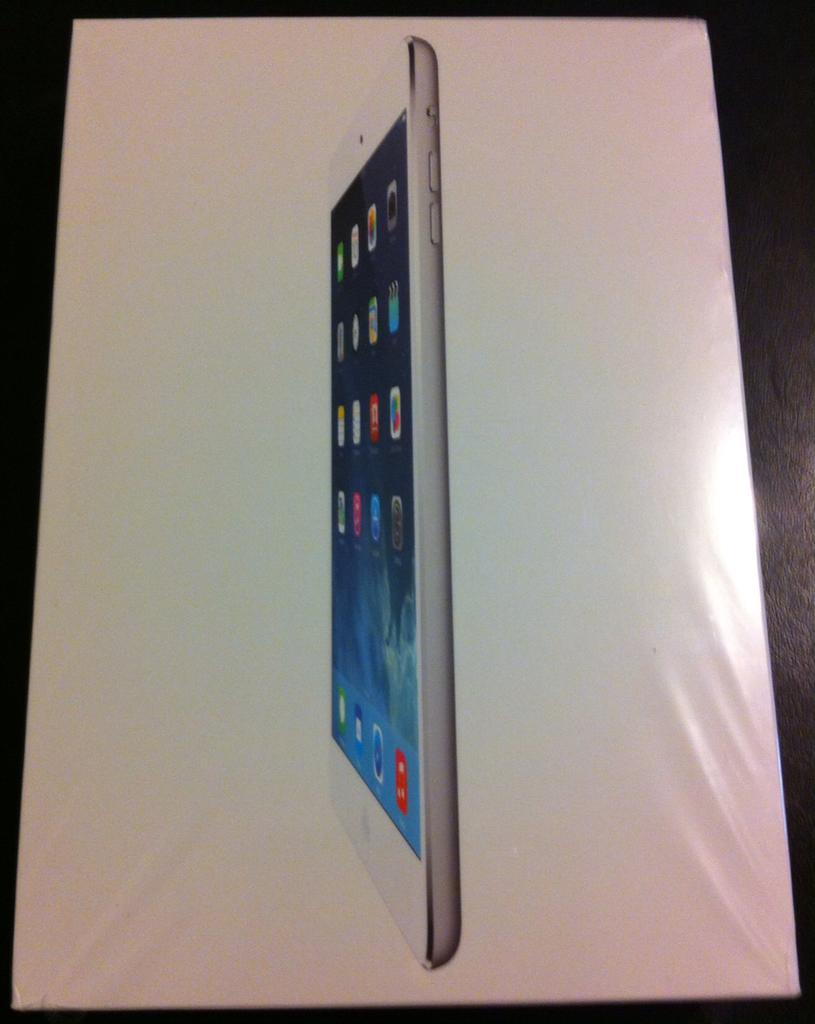What is the main object in the image? There is a screen in the image. What can be seen on the screen? A mobile phone is visible on the screen. How does the dirt on the stick affect the comparison between the two objects in the image? There is no dirt or stick present in the image, and therefore no such comparison can be made. 